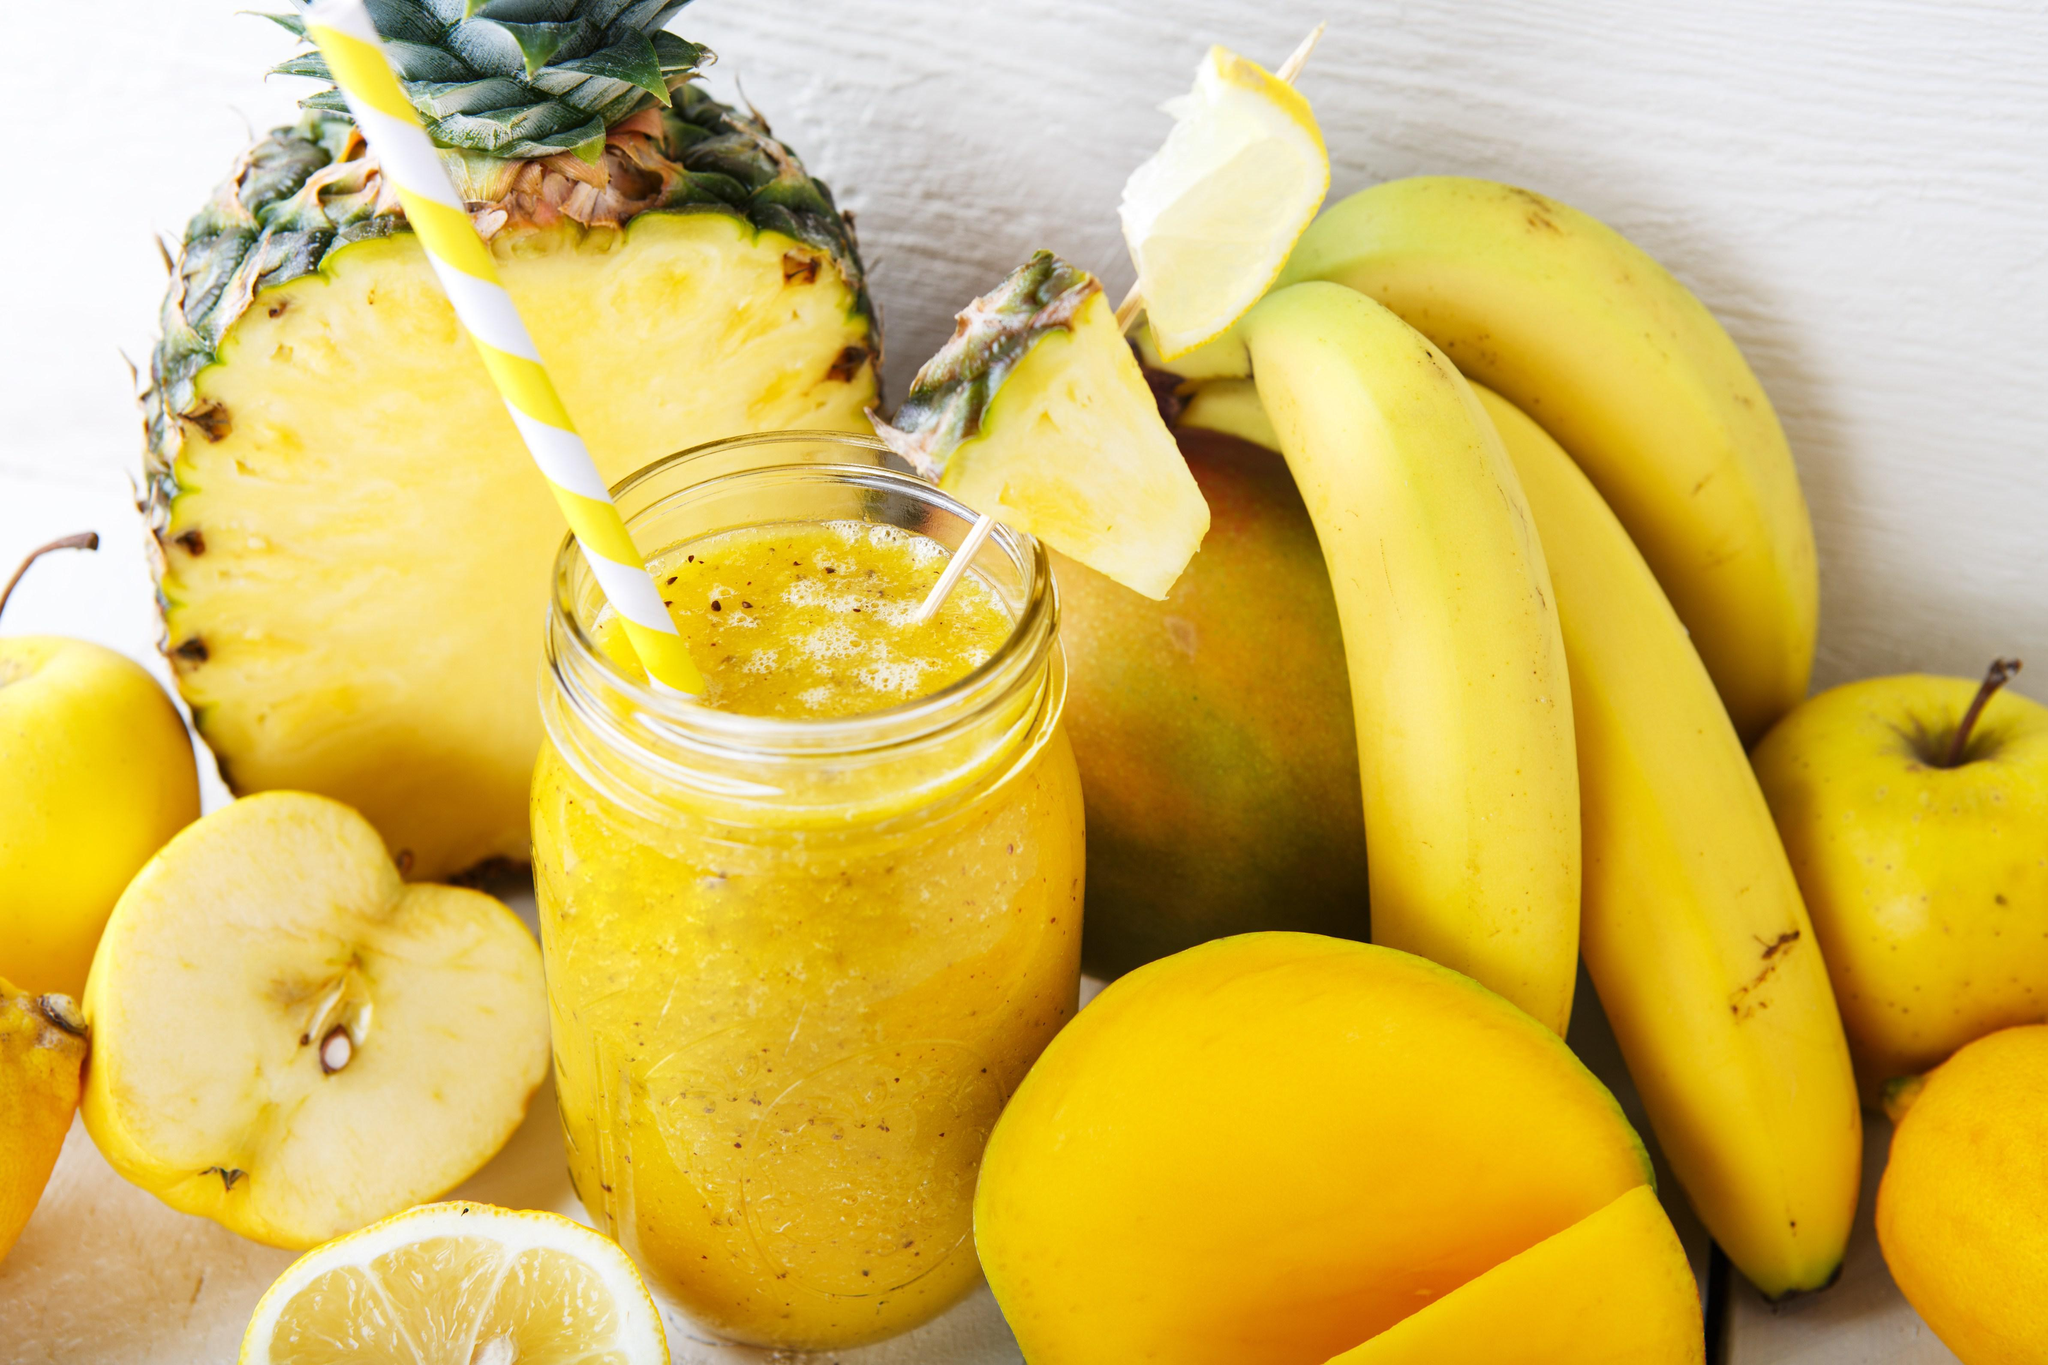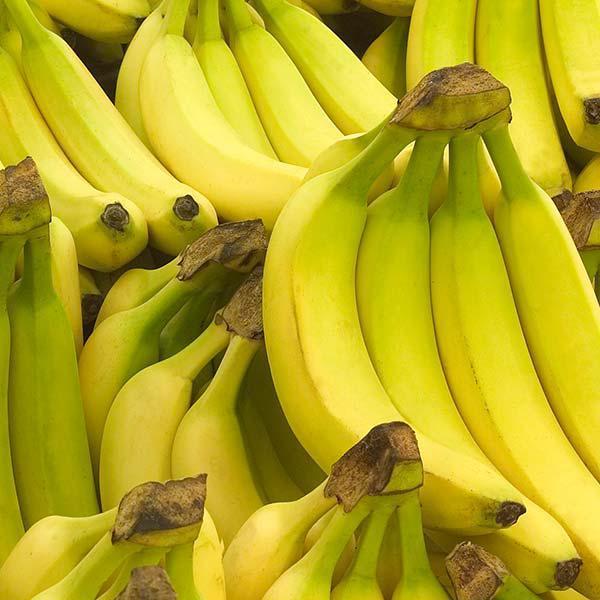The first image is the image on the left, the second image is the image on the right. Examine the images to the left and right. Is the description "One image features a pineapple, bananas and other fruit along with a beverage in a glass, and the other image features only bunches of bananas." accurate? Answer yes or no. Yes. The first image is the image on the left, the second image is the image on the right. For the images shown, is this caption "One image has only bananas and the other has fruit and a fruit smoothie." true? Answer yes or no. Yes. 